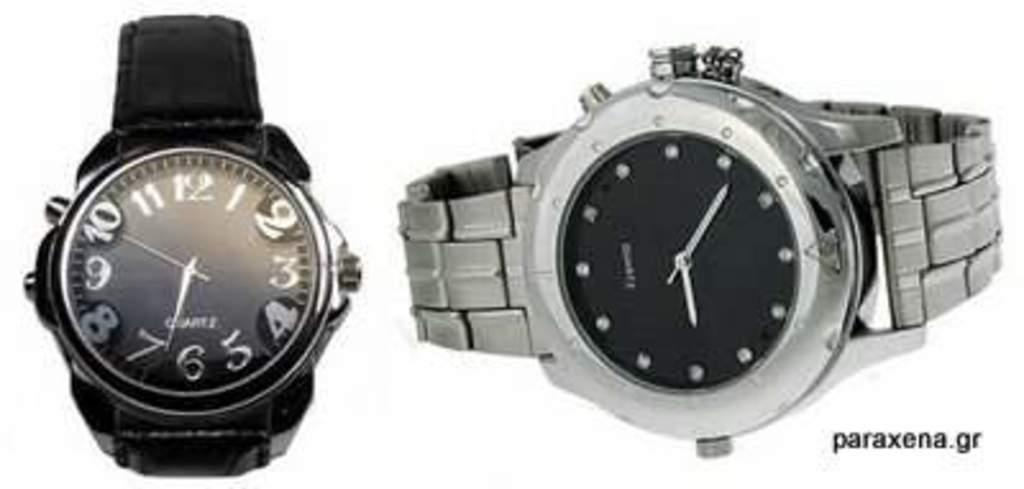<image>
Describe the image concisely. A black and a silver watch are displayed on a white backdrop on paraxena.gr. 